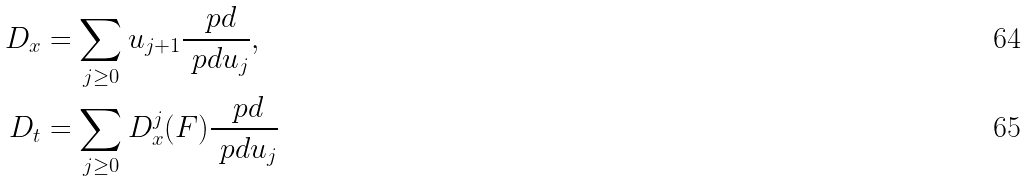Convert formula to latex. <formula><loc_0><loc_0><loc_500><loc_500>D _ { x } & = \sum _ { j \geq 0 } u _ { j + 1 } \frac { \ p d } { \ p d u _ { j } } , \\ D _ { t } & = \sum _ { j \geq 0 } D _ { x } ^ { j } ( F ) \frac { \ p d } { \ p d u _ { j } }</formula> 